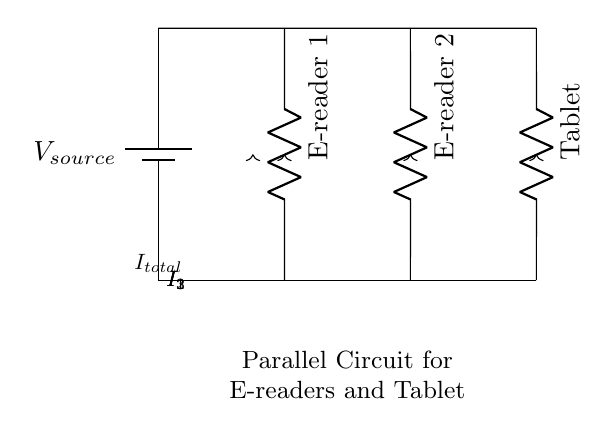What is the source component in this circuit? The component supplying power in the circuit is labeled as a battery, which is crucial since it's the source providing voltage to the entire setup.
Answer: battery How many devices are being powered in this circuit? There are three devices drawn in the circuit: two e-readers and one tablet, confirmed by the individual resistor labels next to each device.
Answer: three What is the type of circuit shown? The circuit consists of several components connected in parallel, evidenced by the multiple branches from the voltage source leading to each device independently.
Answer: parallel What is the total current in the circuit? The total current can be inferred from the notation indicating it flows towards the source and is distributed among the devices, but the specific value is not shown in the diagram.
Answer: I_total Which device has the current labeled as I_1? The current labeled I_1 flows through the first e-reader as indicated by the label next to its resistor in the diagram.
Answer: E-reader 1 How does the current distribute in a parallel circuit? In a parallel circuit, the total current from the source splits into individual currents for each device, and the sum of those individual currents equals the total current supplied by the source.
Answer: splits What would happen if one of the devices is removed from this circuit? If one device is removed, the other devices would continue to operate normally because they are connected independently, maintaining the overall circuit functionality.
Answer: remain functional 